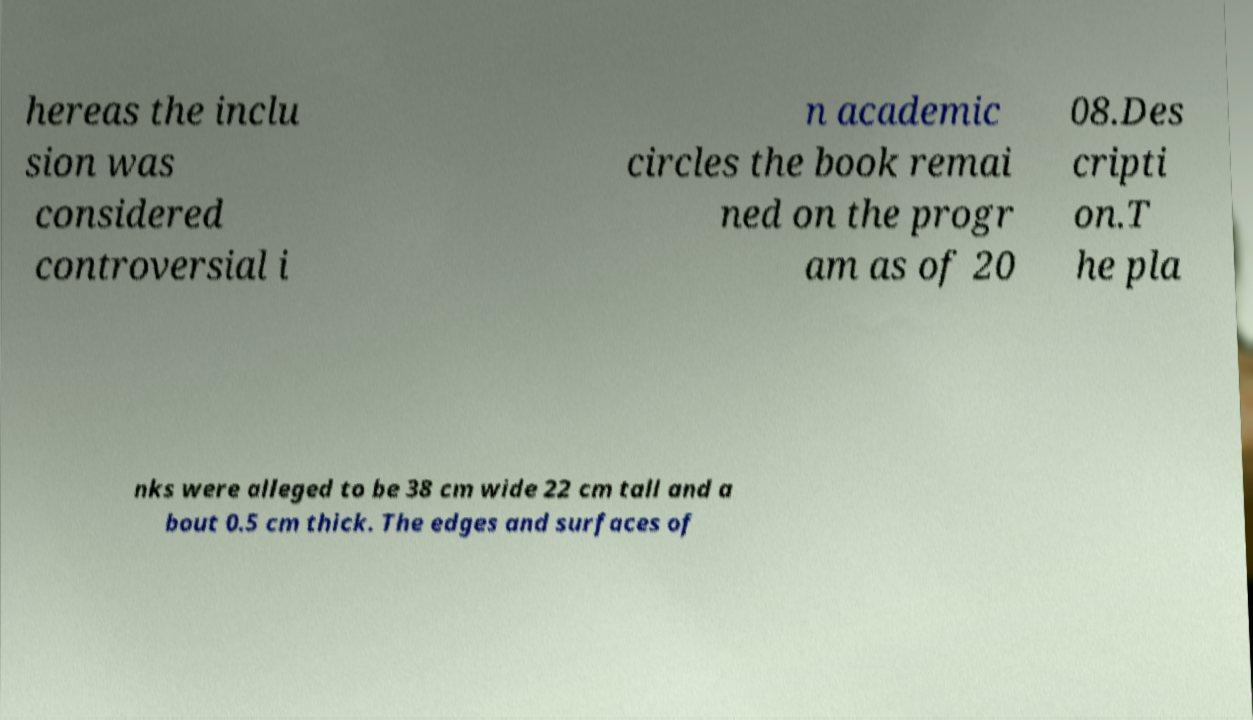Can you accurately transcribe the text from the provided image for me? hereas the inclu sion was considered controversial i n academic circles the book remai ned on the progr am as of 20 08.Des cripti on.T he pla nks were alleged to be 38 cm wide 22 cm tall and a bout 0.5 cm thick. The edges and surfaces of 